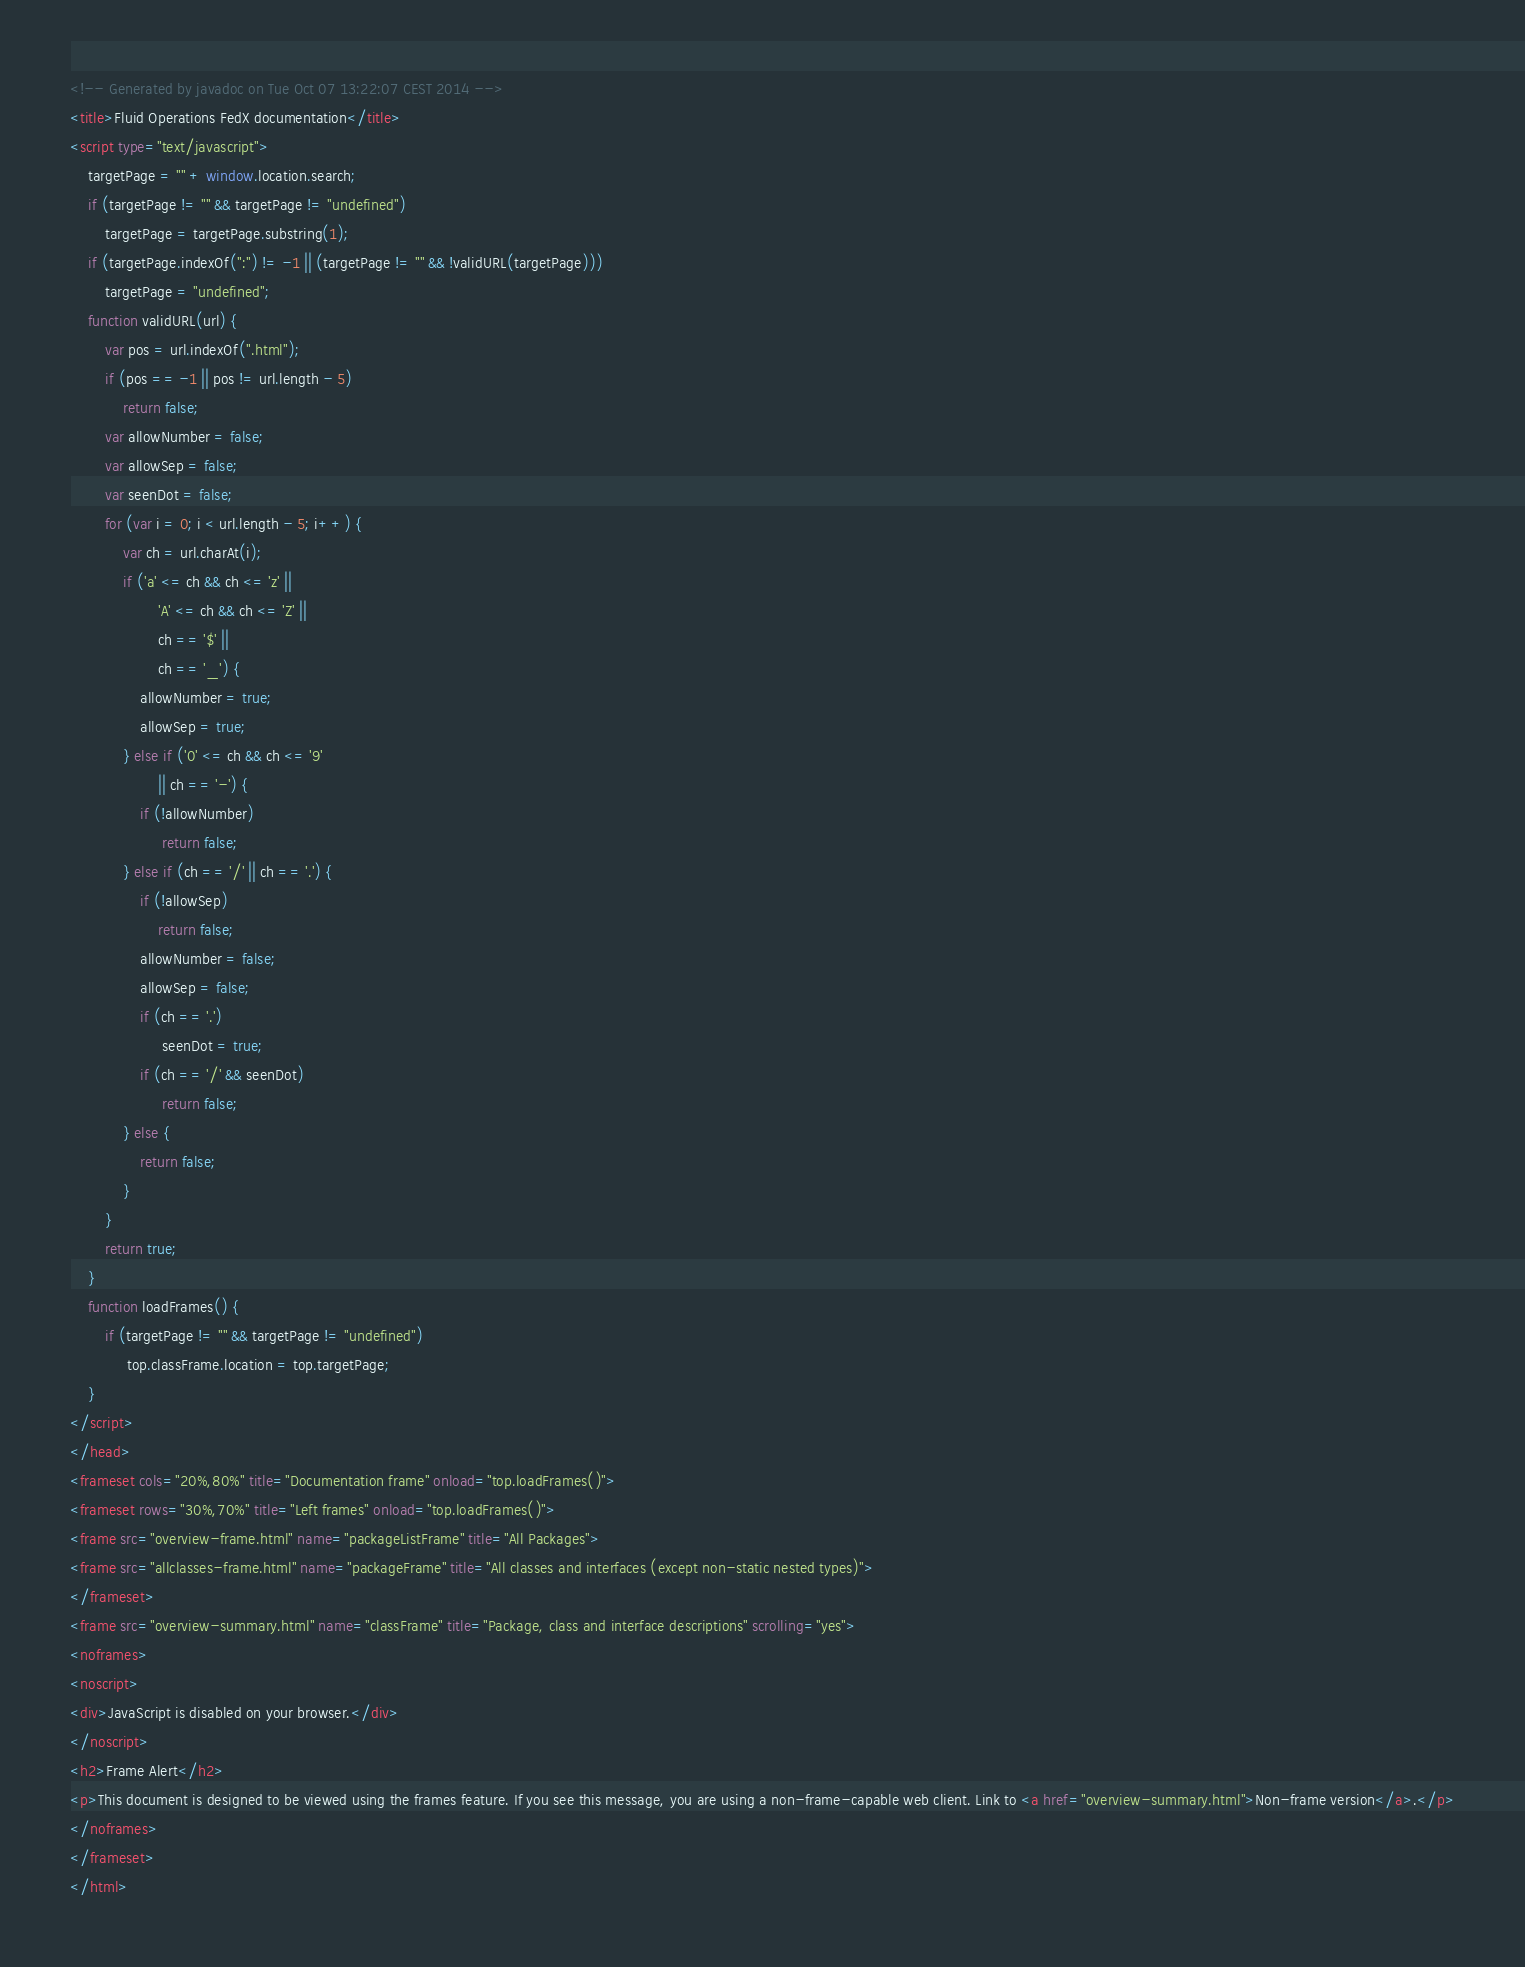Convert code to text. <code><loc_0><loc_0><loc_500><loc_500><_HTML_><!-- Generated by javadoc on Tue Oct 07 13:22:07 CEST 2014 -->
<title>Fluid Operations FedX documentation</title>
<script type="text/javascript">
    targetPage = "" + window.location.search;
    if (targetPage != "" && targetPage != "undefined")
        targetPage = targetPage.substring(1);
    if (targetPage.indexOf(":") != -1 || (targetPage != "" && !validURL(targetPage)))
        targetPage = "undefined";
    function validURL(url) {
        var pos = url.indexOf(".html");
        if (pos == -1 || pos != url.length - 5)
            return false;
        var allowNumber = false;
        var allowSep = false;
        var seenDot = false;
        for (var i = 0; i < url.length - 5; i++) {
            var ch = url.charAt(i);
            if ('a' <= ch && ch <= 'z' ||
                    'A' <= ch && ch <= 'Z' ||
                    ch == '$' ||
                    ch == '_') {
                allowNumber = true;
                allowSep = true;
            } else if ('0' <= ch && ch <= '9'
                    || ch == '-') {
                if (!allowNumber)
                     return false;
            } else if (ch == '/' || ch == '.') {
                if (!allowSep)
                    return false;
                allowNumber = false;
                allowSep = false;
                if (ch == '.')
                     seenDot = true;
                if (ch == '/' && seenDot)
                     return false;
            } else {
                return false;
            }
        }
        return true;
    }
    function loadFrames() {
        if (targetPage != "" && targetPage != "undefined")
             top.classFrame.location = top.targetPage;
    }
</script>
</head>
<frameset cols="20%,80%" title="Documentation frame" onload="top.loadFrames()">
<frameset rows="30%,70%" title="Left frames" onload="top.loadFrames()">
<frame src="overview-frame.html" name="packageListFrame" title="All Packages">
<frame src="allclasses-frame.html" name="packageFrame" title="All classes and interfaces (except non-static nested types)">
</frameset>
<frame src="overview-summary.html" name="classFrame" title="Package, class and interface descriptions" scrolling="yes">
<noframes>
<noscript>
<div>JavaScript is disabled on your browser.</div>
</noscript>
<h2>Frame Alert</h2>
<p>This document is designed to be viewed using the frames feature. If you see this message, you are using a non-frame-capable web client. Link to <a href="overview-summary.html">Non-frame version</a>.</p>
</noframes>
</frameset>
</html>
</code> 